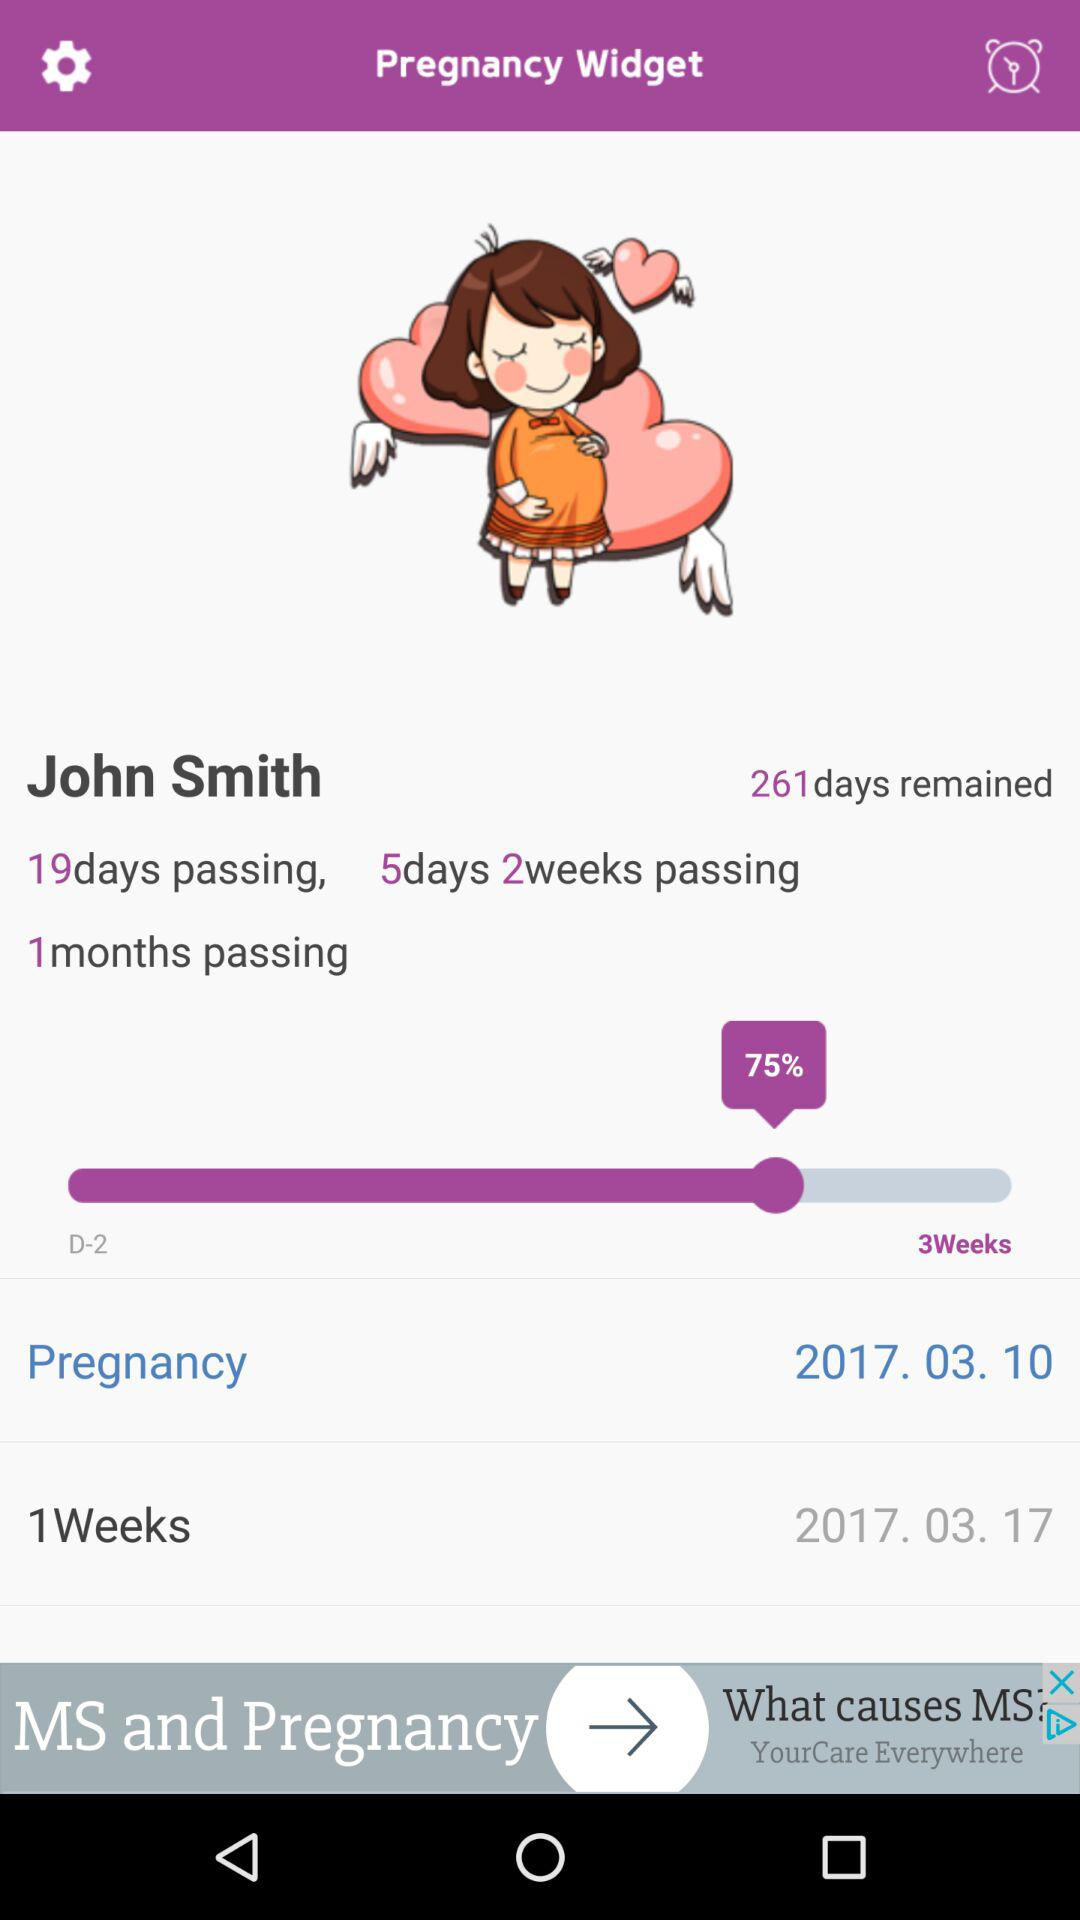What is the date? The dates are March 10, 2017 and March 17, 2017. 